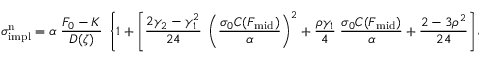<formula> <loc_0><loc_0><loc_500><loc_500>\sigma _ { i m p l } ^ { n } = \alpha \, { \frac { F _ { 0 } - K } { D ( \zeta ) } } \, \left \{ 1 + \left [ { \frac { 2 \gamma _ { 2 } - \gamma _ { 1 } ^ { 2 } } { 2 4 } } \, \left ( { \frac { \sigma _ { 0 } C ( F _ { m i d } ) } { \alpha } } \right ) ^ { 2 } + { \frac { \rho \gamma _ { 1 } } { 4 } } \, { \frac { \sigma _ { 0 } C ( F _ { m i d } ) } { \alpha } } + { \frac { 2 - 3 \rho ^ { 2 } } { 2 4 } } \right ] \varepsilon \right \} .</formula> 